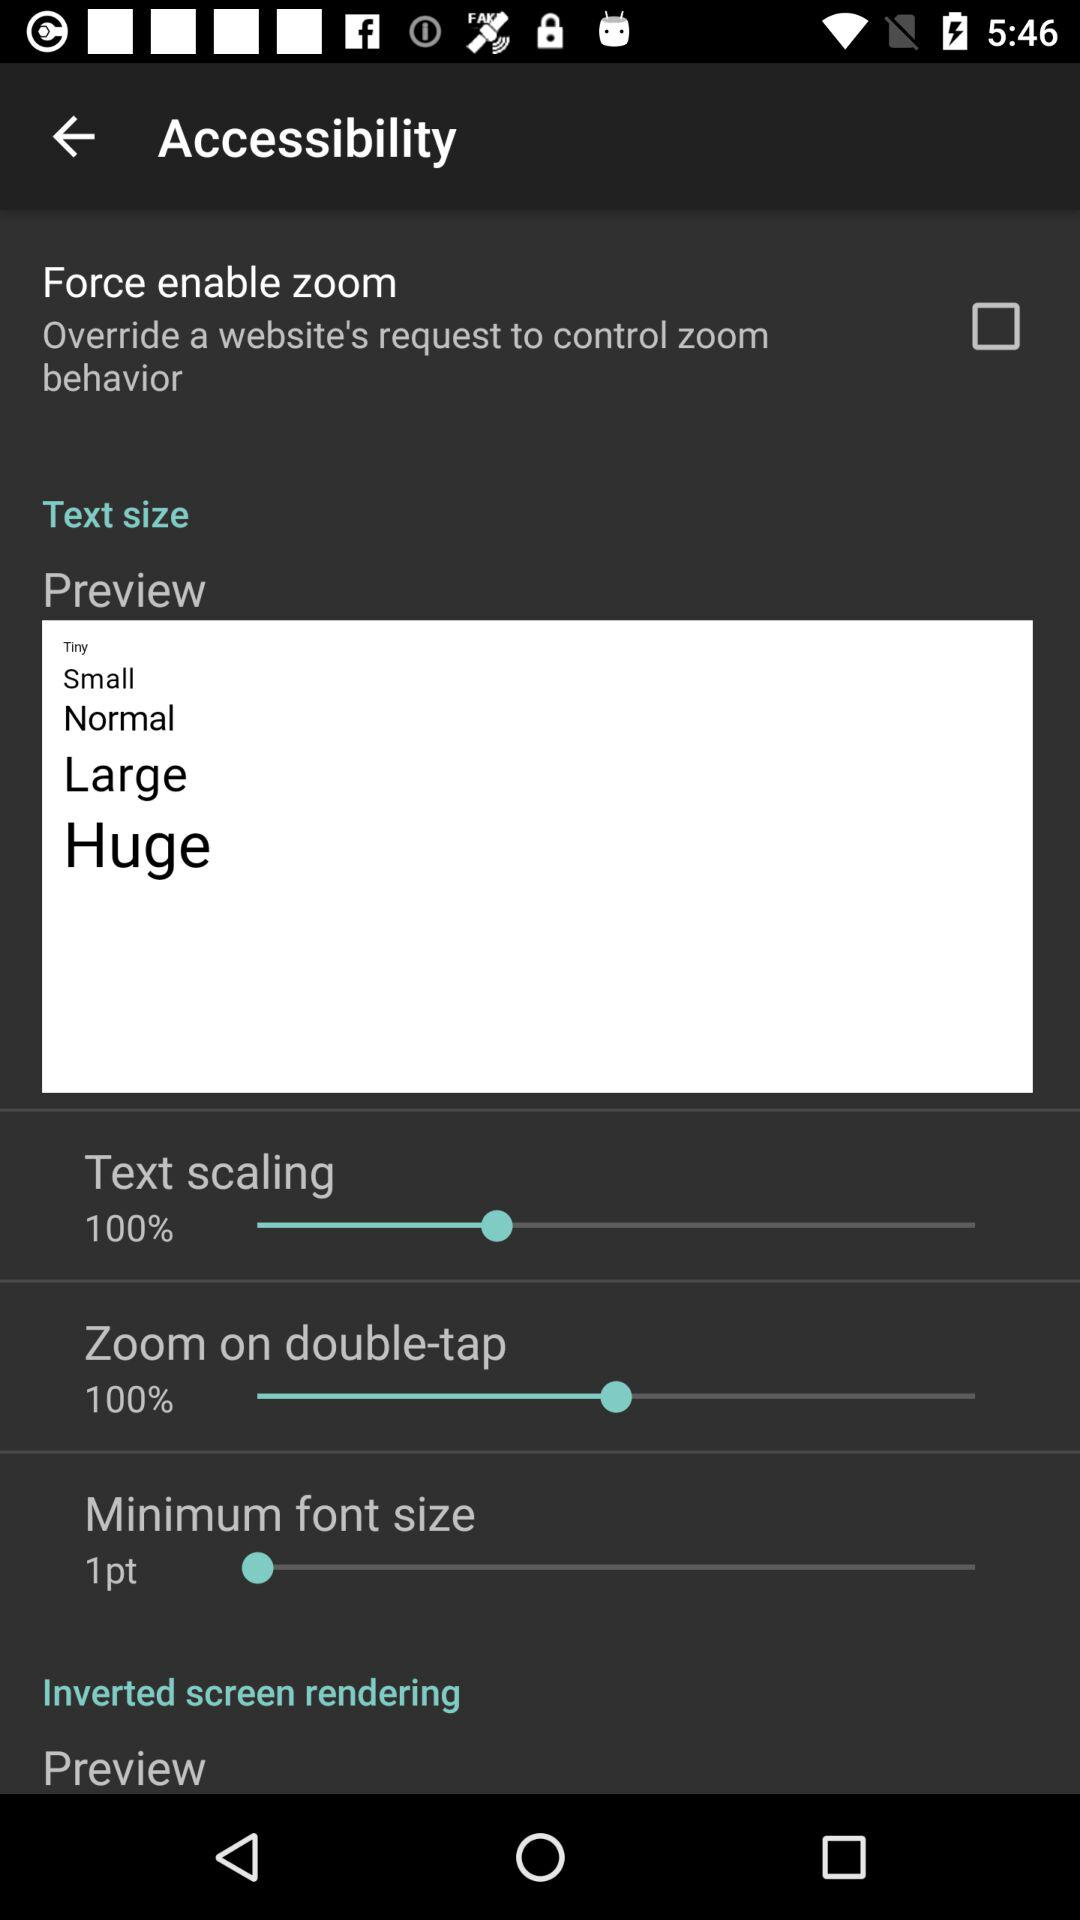What is the minimum font size? The minimum font size is 1 point. 